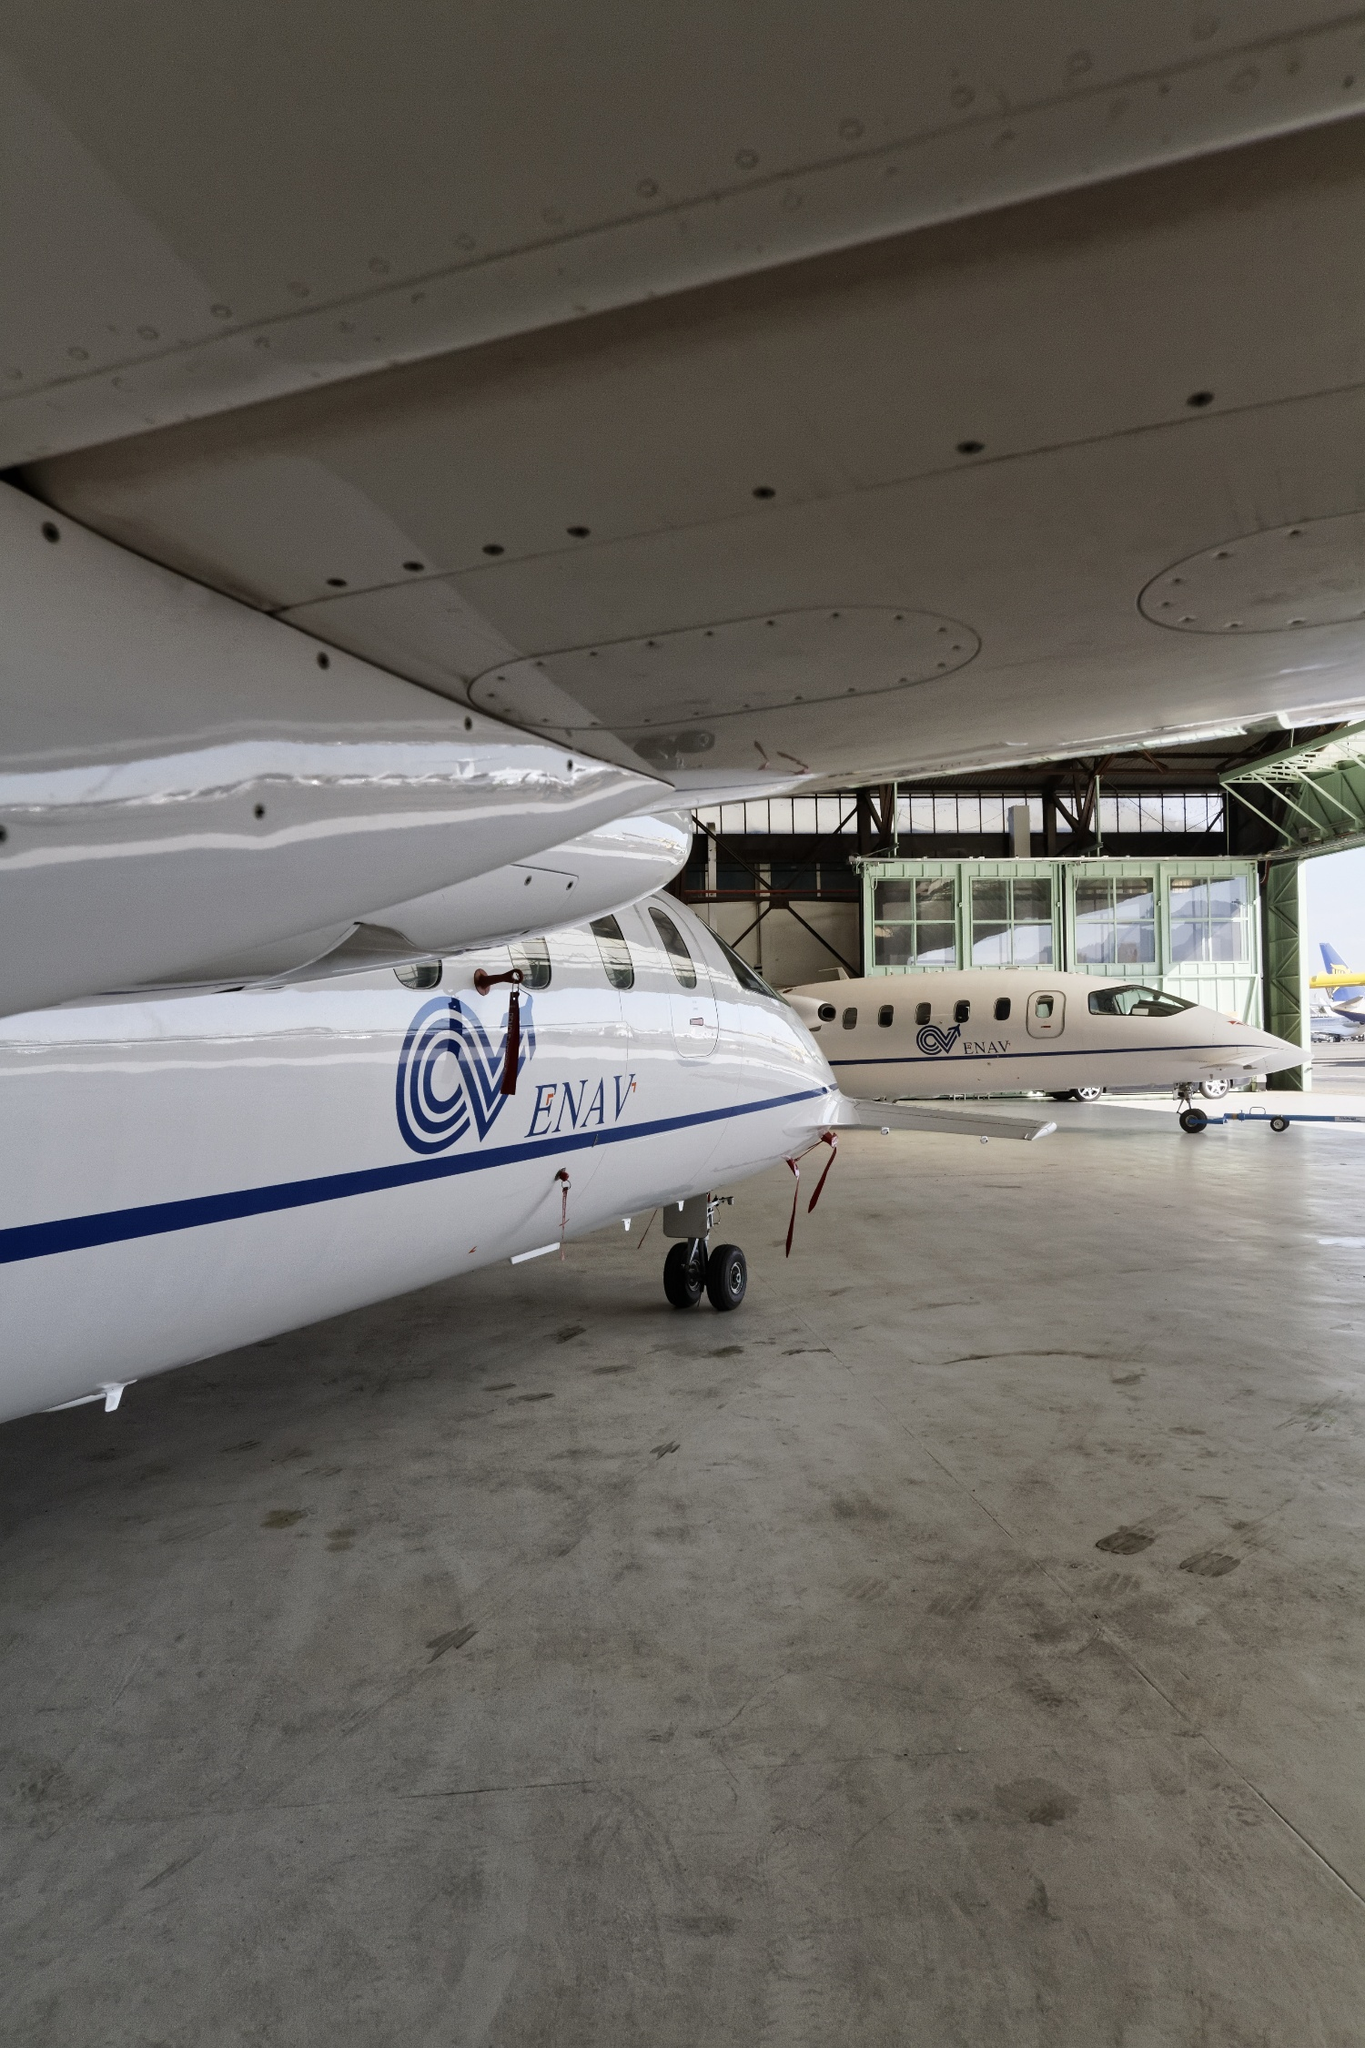If these airplanes were part of a movie, what role would they play? In a thrilling action movie, these airplanes could play the role of secret agents' high-tech transport vehicles. The larger airplane might be a sophisticated command center in the sky, equipped with advanced technology and communication tools, enabling the agents to plan and coordinate their missions. The smaller airplane could be a fast and nimble jet, used for quick getaways and airborne chases. Throughout the movie, scenes would feature dramatic take-offs and landings in diverse, exotic locations. The hangar itself would serve as the agents' base of operations, where crucial planning and strategizing take place. 